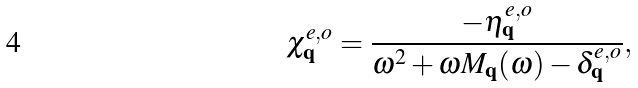Convert formula to latex. <formula><loc_0><loc_0><loc_500><loc_500>\chi ^ { e , o } _ { \mathbf q } = \frac { - \eta ^ { e , o } _ { \mathbf q } } { \omega ^ { 2 } + \omega M _ { \mathbf q } ( \omega ) - \delta ^ { e , o } _ { \mathbf q } } ,</formula> 